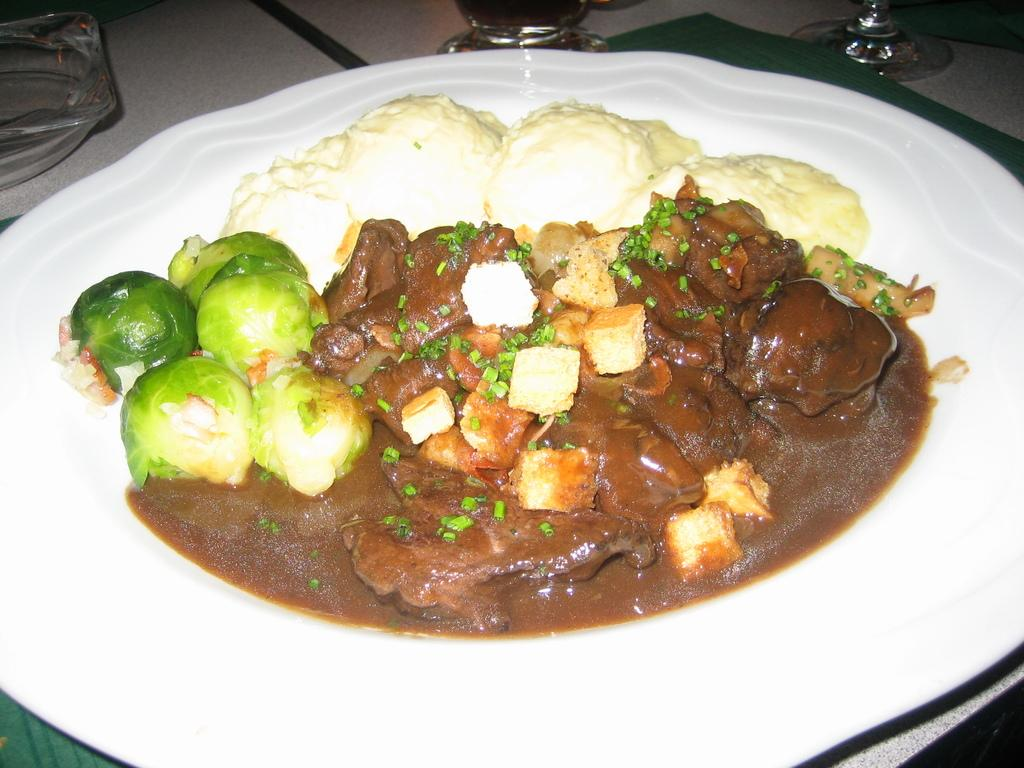What color is the plate that is visible in the image? The plate is white in color. What is on top of the plate in the image? There is a dish on the plate. What type of arch can be seen supporting the plate in the image? There is no arch present in the image; the plate is resting on a flat surface. 